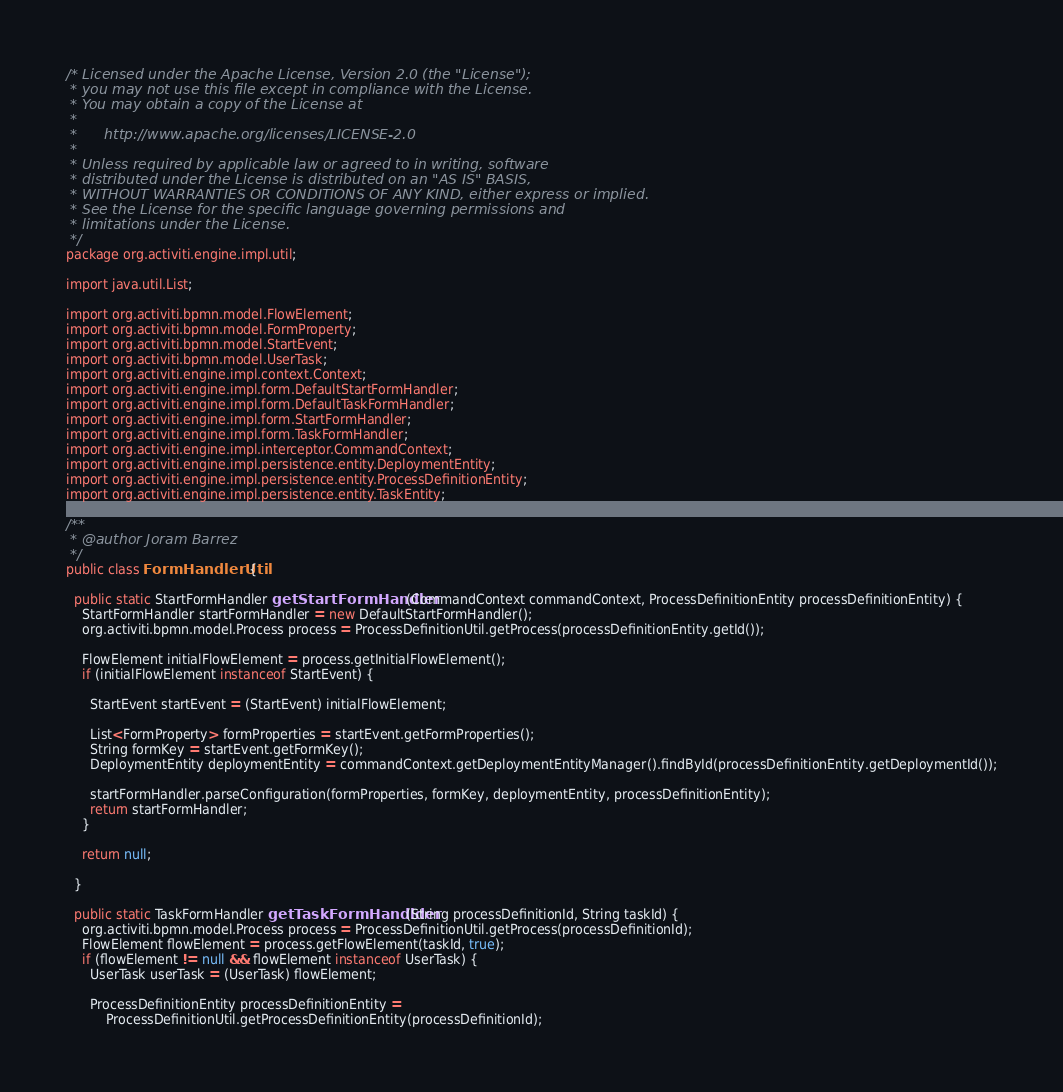<code> <loc_0><loc_0><loc_500><loc_500><_Java_>/* Licensed under the Apache License, Version 2.0 (the "License");
 * you may not use this file except in compliance with the License.
 * You may obtain a copy of the License at
 * 
 *      http://www.apache.org/licenses/LICENSE-2.0
 * 
 * Unless required by applicable law or agreed to in writing, software
 * distributed under the License is distributed on an "AS IS" BASIS,
 * WITHOUT WARRANTIES OR CONDITIONS OF ANY KIND, either express or implied.
 * See the License for the specific language governing permissions and
 * limitations under the License.
 */
package org.activiti.engine.impl.util;

import java.util.List;

import org.activiti.bpmn.model.FlowElement;
import org.activiti.bpmn.model.FormProperty;
import org.activiti.bpmn.model.StartEvent;
import org.activiti.bpmn.model.UserTask;
import org.activiti.engine.impl.context.Context;
import org.activiti.engine.impl.form.DefaultStartFormHandler;
import org.activiti.engine.impl.form.DefaultTaskFormHandler;
import org.activiti.engine.impl.form.StartFormHandler;
import org.activiti.engine.impl.form.TaskFormHandler;
import org.activiti.engine.impl.interceptor.CommandContext;
import org.activiti.engine.impl.persistence.entity.DeploymentEntity;
import org.activiti.engine.impl.persistence.entity.ProcessDefinitionEntity;
import org.activiti.engine.impl.persistence.entity.TaskEntity;

/**
 * @author Joram Barrez
 */
public class FormHandlerUtil {
  
  public static StartFormHandler getStartFormHandler(CommandContext commandContext, ProcessDefinitionEntity processDefinitionEntity) {
    StartFormHandler startFormHandler = new DefaultStartFormHandler();
    org.activiti.bpmn.model.Process process = ProcessDefinitionUtil.getProcess(processDefinitionEntity.getId());
    
    FlowElement initialFlowElement = process.getInitialFlowElement();
    if (initialFlowElement instanceof StartEvent) {
      
      StartEvent startEvent = (StartEvent) initialFlowElement;
      
      List<FormProperty> formProperties = startEvent.getFormProperties();
      String formKey = startEvent.getFormKey();
      DeploymentEntity deploymentEntity = commandContext.getDeploymentEntityManager().findById(processDefinitionEntity.getDeploymentId());
      
      startFormHandler.parseConfiguration(formProperties, formKey, deploymentEntity, processDefinitionEntity);
      return startFormHandler;
    }
    
    return null;
    
  }
  
  public static TaskFormHandler getTaskFormHandlder(String processDefinitionId, String taskId) {
    org.activiti.bpmn.model.Process process = ProcessDefinitionUtil.getProcess(processDefinitionId);
    FlowElement flowElement = process.getFlowElement(taskId, true);
    if (flowElement != null && flowElement instanceof UserTask) {
      UserTask userTask = (UserTask) flowElement;
      
      ProcessDefinitionEntity processDefinitionEntity = 
          ProcessDefinitionUtil.getProcessDefinitionEntity(processDefinitionId);</code> 